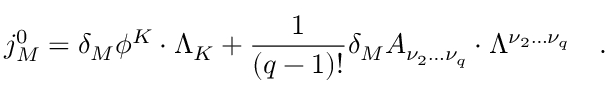Convert formula to latex. <formula><loc_0><loc_0><loc_500><loc_500>j _ { M } ^ { 0 } = \delta _ { M } \phi ^ { K } \cdot \Lambda _ { K } + \frac { 1 } \left ( q - 1 \right ) ! } \delta _ { M } A _ { \nu _ { 2 } \dots \nu _ { q } } \cdot \Lambda ^ { \nu _ { 2 } \dots \nu _ { q } } \quad .</formula> 